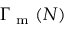<formula> <loc_0><loc_0><loc_500><loc_500>\Gamma _ { m } ( N )</formula> 